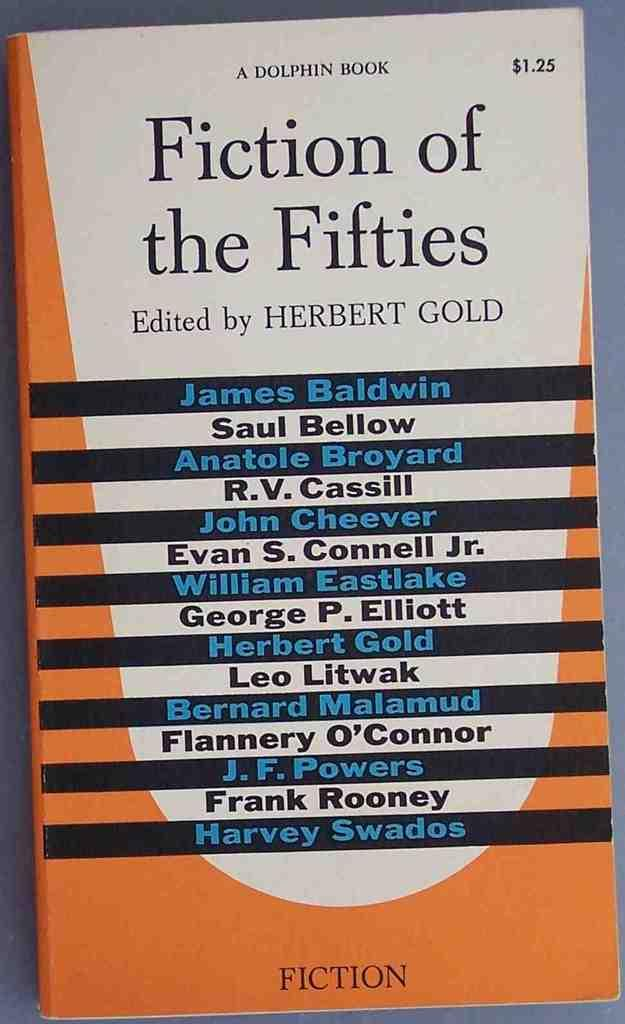<image>
Relay a brief, clear account of the picture shown. A book cover bears the title Fiction of the Fifties and lists various authors. 